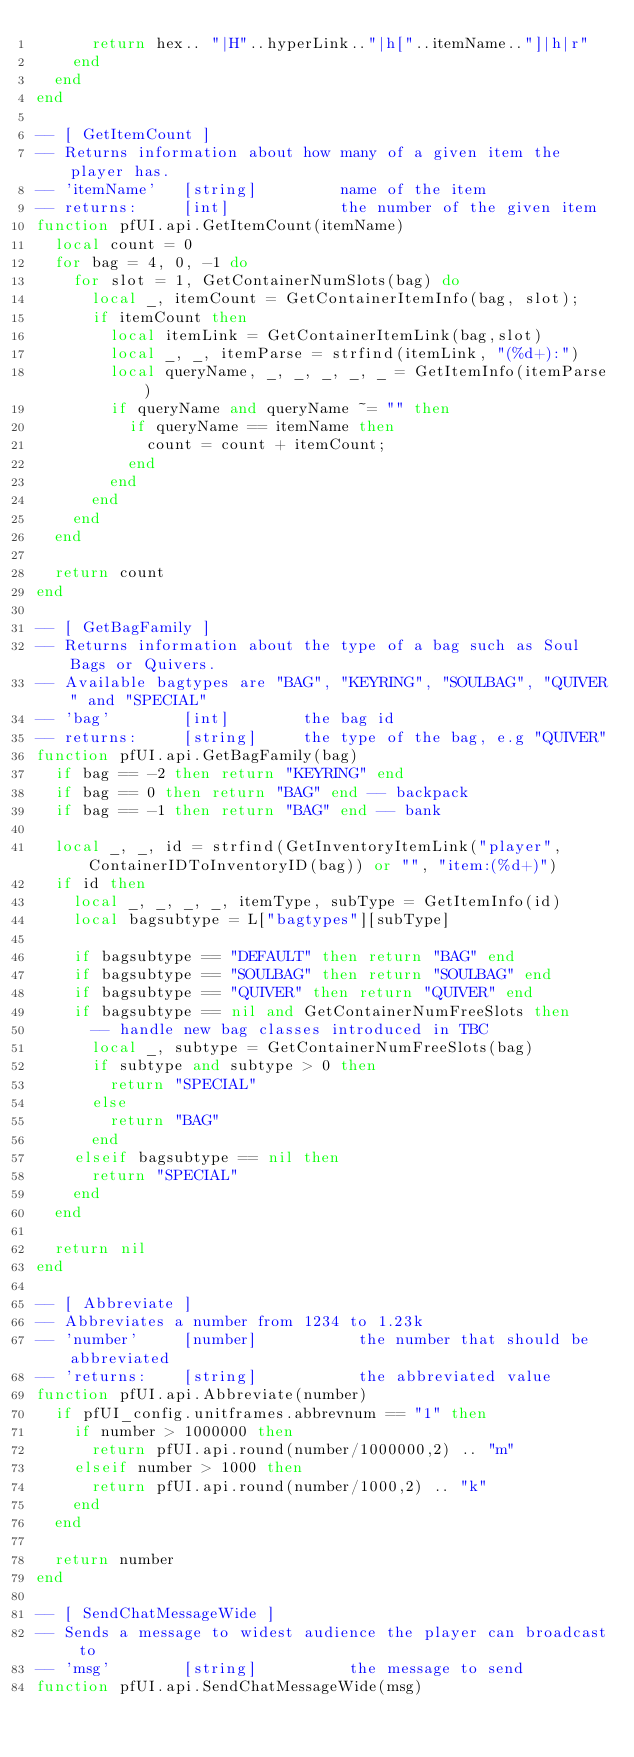<code> <loc_0><loc_0><loc_500><loc_500><_Lua_>      return hex.. "|H"..hyperLink.."|h["..itemName.."]|h|r"
    end
  end
end

-- [ GetItemCount ]
-- Returns information about how many of a given item the player has.
-- 'itemName'   [string]         name of the item
-- returns:     [int]            the number of the given item
function pfUI.api.GetItemCount(itemName)
  local count = 0
  for bag = 4, 0, -1 do
    for slot = 1, GetContainerNumSlots(bag) do
      local _, itemCount = GetContainerItemInfo(bag, slot);
      if itemCount then
        local itemLink = GetContainerItemLink(bag,slot)
        local _, _, itemParse = strfind(itemLink, "(%d+):")
        local queryName, _, _, _, _, _ = GetItemInfo(itemParse)
        if queryName and queryName ~= "" then
          if queryName == itemName then
            count = count + itemCount;
          end
        end
      end
    end
  end

  return count
end

-- [ GetBagFamily ]
-- Returns information about the type of a bag such as Soul Bags or Quivers.
-- Available bagtypes are "BAG", "KEYRING", "SOULBAG", "QUIVER" and "SPECIAL"
-- 'bag'        [int]        the bag id
-- returns:     [string]     the type of the bag, e.g "QUIVER"
function pfUI.api.GetBagFamily(bag)
  if bag == -2 then return "KEYRING" end
  if bag == 0 then return "BAG" end -- backpack
  if bag == -1 then return "BAG" end -- bank

  local _, _, id = strfind(GetInventoryItemLink("player", ContainerIDToInventoryID(bag)) or "", "item:(%d+)")
  if id then
    local _, _, _, _, itemType, subType = GetItemInfo(id)
    local bagsubtype = L["bagtypes"][subType]

    if bagsubtype == "DEFAULT" then return "BAG" end
    if bagsubtype == "SOULBAG" then return "SOULBAG" end
    if bagsubtype == "QUIVER" then return "QUIVER" end
    if bagsubtype == nil and GetContainerNumFreeSlots then
      -- handle new bag classes introduced in TBC
      local _, subtype = GetContainerNumFreeSlots(bag)
      if subtype and subtype > 0 then
        return "SPECIAL"
      else
        return "BAG"
      end
    elseif bagsubtype == nil then
      return "SPECIAL"
    end
  end

  return nil
end

-- [ Abbreviate ]
-- Abbreviates a number from 1234 to 1.23k
-- 'number'     [number]           the number that should be abbreviated
-- 'returns:    [string]           the abbreviated value
function pfUI.api.Abbreviate(number)
  if pfUI_config.unitframes.abbrevnum == "1" then
    if number > 1000000 then
      return pfUI.api.round(number/1000000,2) .. "m"
    elseif number > 1000 then
      return pfUI.api.round(number/1000,2) .. "k"
    end
  end

  return number
end

-- [ SendChatMessageWide ]
-- Sends a message to widest audience the player can broadcast to
-- 'msg'        [string]          the message to send
function pfUI.api.SendChatMessageWide(msg)</code> 